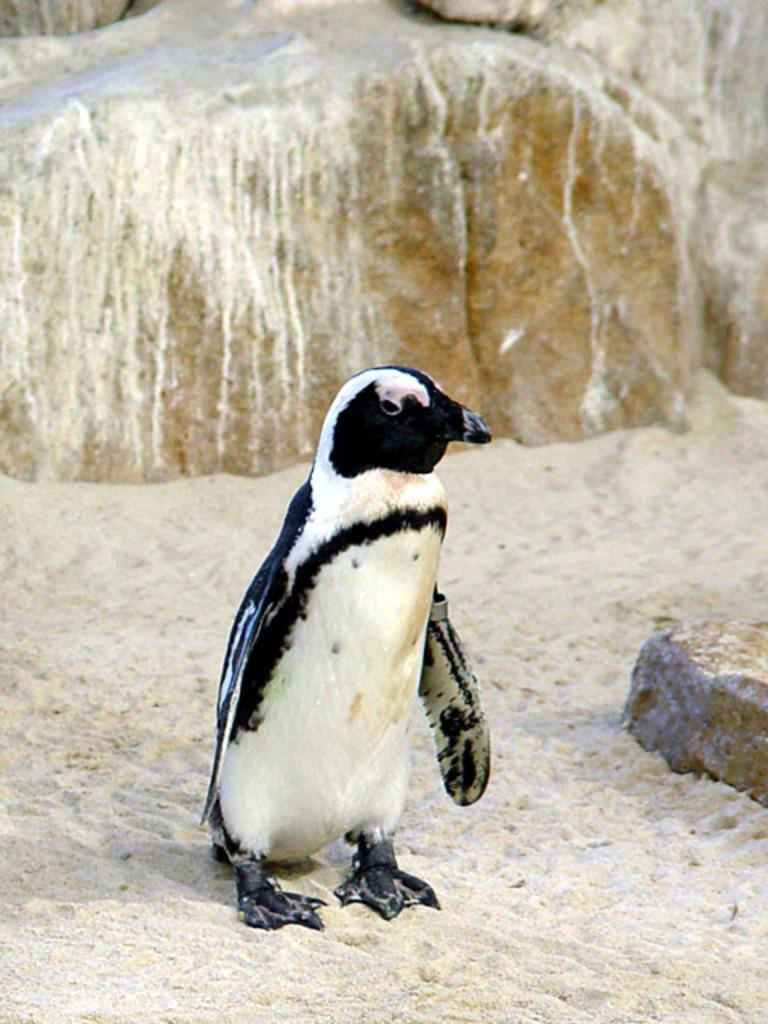What type of animal is in the image? There is a penguin in the image. Where is the penguin located? The penguin is standing on land. What is the terrain like where the penguin is standing? The land has rocks. What can be seen in the background of the image? There are rocks in the background of the image. What type of coil is visible in the image? There is no coil present in the image; it features a penguin standing on land with rocks. Can you see any signs of industry in the image? There is no indication of industry in the image; it shows a penguin in a natural setting with rocks. 